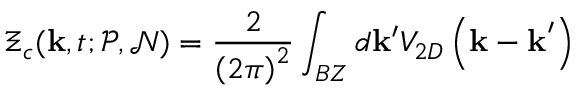Convert formula to latex. <formula><loc_0><loc_0><loc_500><loc_500>\Xi _ { c } ( k , t ; \mathcal { P } , \mathcal { N } ) = \frac { 2 } { \left ( 2 \pi \right ) ^ { 2 } } \int _ { B Z } d k ^ { \prime } V _ { 2 D } \left ( k - k ^ { \prime } \right )</formula> 